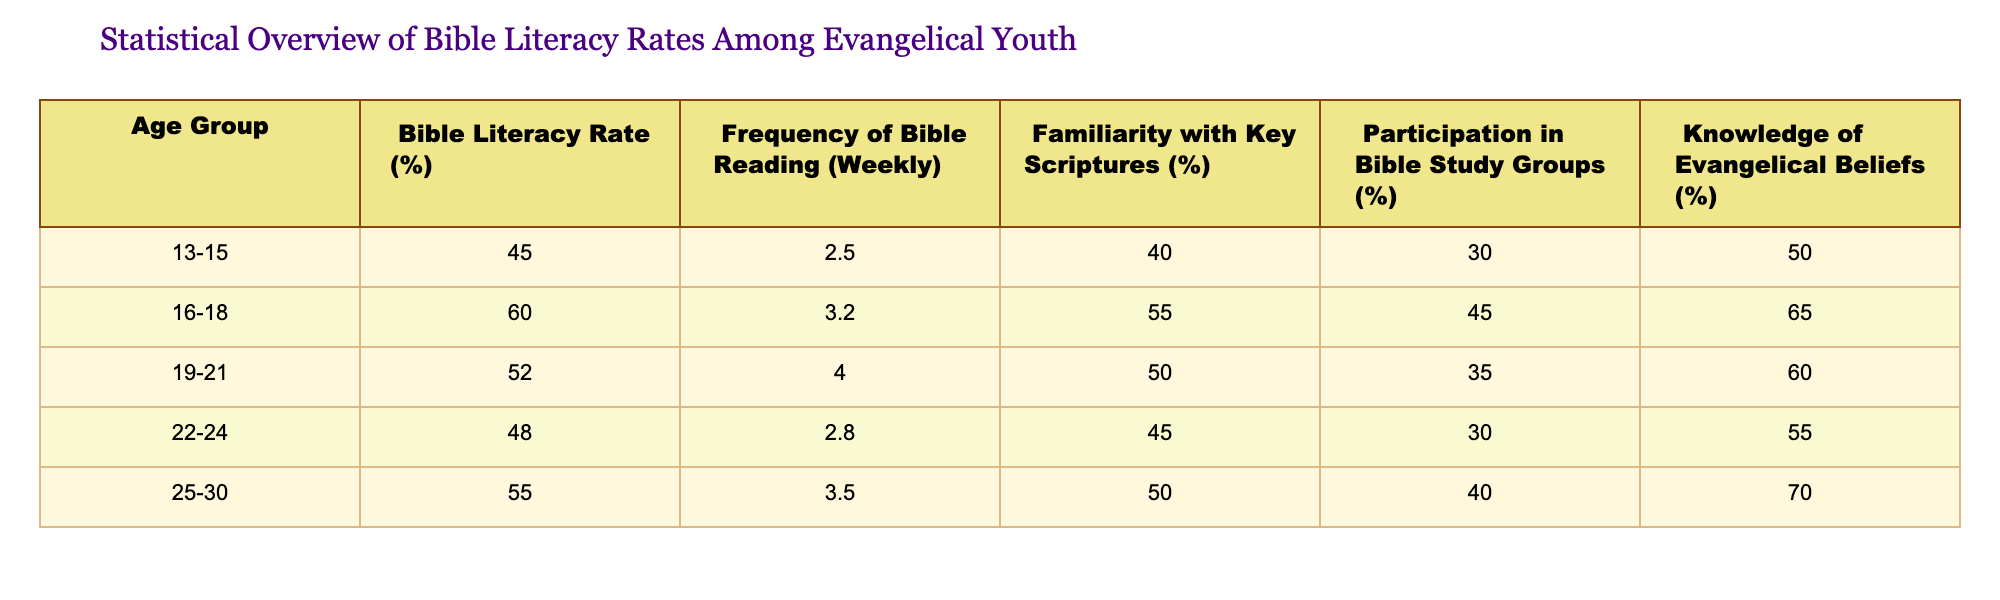What is the Bible Literacy Rate for the age group 16-18? Referring to the table, the Bible Literacy Rate for the age group 16-18 is directly listed as 60%.
Answer: 60% What percentage of the 19-21 age group participates in Bible Study Groups? The table shows that 35% of the 19-21 age group participates in Bible Study Groups.
Answer: 35% Which age group has the highest Familiarity with Key Scriptures percentage? Analyzing the Familiarity with Key Scriptures column, the highest percentage is 55% for the age group 16-18.
Answer: 16-18 What is the average Frequency of Bible Reading for all age groups combined? To calculate the average, sum the frequencies: (2.5 + 3.2 + 4.0 + 2.8 + 3.5) = 16. Then divide by the number of groups, which is 5: 16 / 5 = 3.2.
Answer: 3.2 Is the Bible Literacy Rate for the 25-30 age group greater than the 22-24 age group? Comparing the two, the Bible Literacy Rate for 25-30 is 55% and for 22-24 is 48%. Thus, 55% is greater than 48%.
Answer: Yes Do all age groups have a Familiarity with Key Scriptures percentage greater than 40%? Checking each group's percentage: 40%, 55%, 50%, 45%, and 50%. Since all groups meet the criterion, the answer is yes.
Answer: Yes What is the difference in Knowledge of Evangelical Beliefs between the 16-18 and 25-30 age groups? The Knowledge of Evangelical Beliefs for 16-18 is 65% and for 25-30 is 70%. The difference is 70% - 65% = 5%.
Answer: 5% Are members of the 13-15 age group more likely to read the Bible weekly compared to those in the 25-30 age group? The Frequency of Bible Reading for 13-15 is 2.5 and for 25-30 is 3.5. Since 2.5 is less than 3.5, it means they are less likely.
Answer: No Which age group shows the lowest Bible Literacy Rate, and what is that rate? The table indicates that the age group 13-15 has the lowest Bible Literacy Rate at 45%.
Answer: 13-15, 45% 